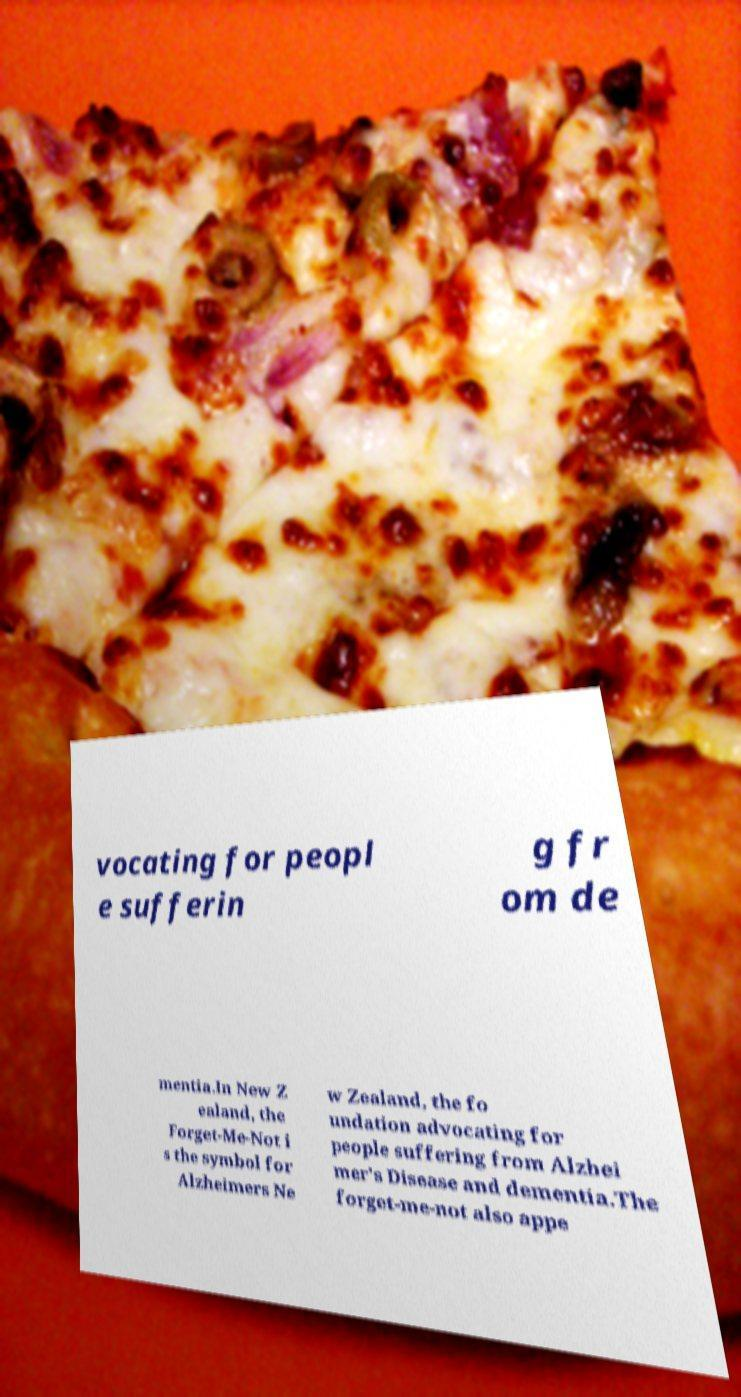For documentation purposes, I need the text within this image transcribed. Could you provide that? vocating for peopl e sufferin g fr om de mentia.In New Z ealand, the Forget-Me-Not i s the symbol for Alzheimers Ne w Zealand, the fo undation advocating for people suffering from Alzhei mer's Disease and dementia.The forget-me-not also appe 